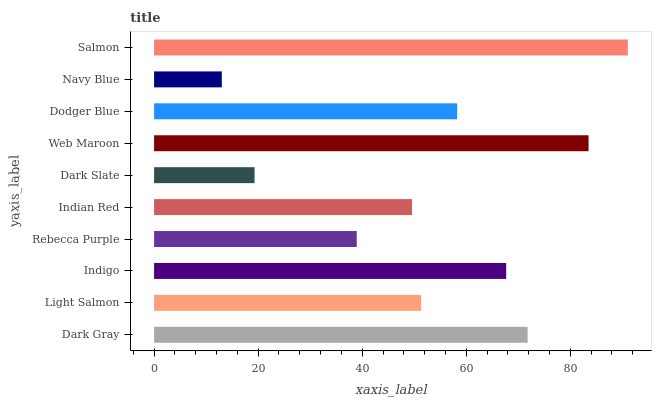Is Navy Blue the minimum?
Answer yes or no. Yes. Is Salmon the maximum?
Answer yes or no. Yes. Is Light Salmon the minimum?
Answer yes or no. No. Is Light Salmon the maximum?
Answer yes or no. No. Is Dark Gray greater than Light Salmon?
Answer yes or no. Yes. Is Light Salmon less than Dark Gray?
Answer yes or no. Yes. Is Light Salmon greater than Dark Gray?
Answer yes or no. No. Is Dark Gray less than Light Salmon?
Answer yes or no. No. Is Dodger Blue the high median?
Answer yes or no. Yes. Is Light Salmon the low median?
Answer yes or no. Yes. Is Salmon the high median?
Answer yes or no. No. Is Web Maroon the low median?
Answer yes or no. No. 